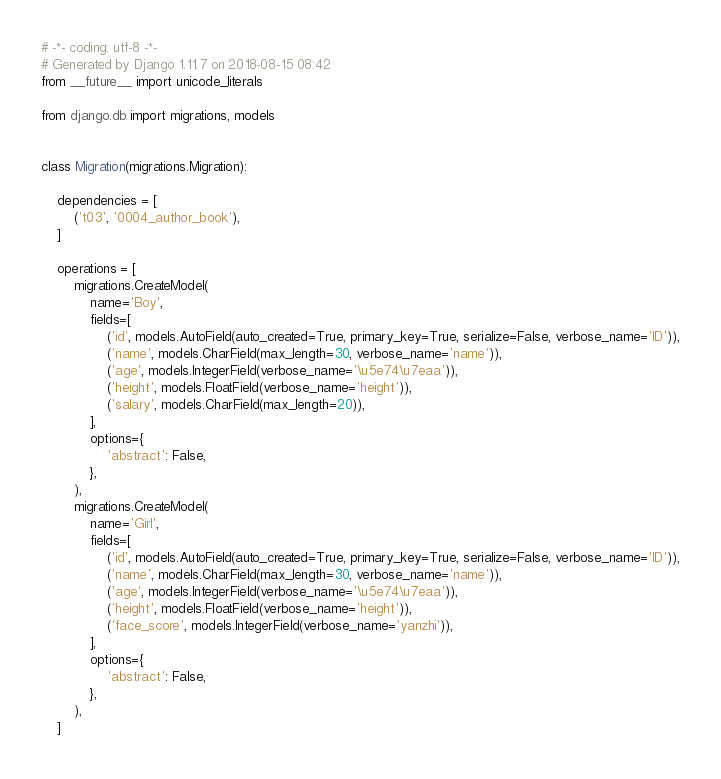<code> <loc_0><loc_0><loc_500><loc_500><_Python_># -*- coding: utf-8 -*-
# Generated by Django 1.11.7 on 2018-08-15 08:42
from __future__ import unicode_literals

from django.db import migrations, models


class Migration(migrations.Migration):

    dependencies = [
        ('t03', '0004_author_book'),
    ]

    operations = [
        migrations.CreateModel(
            name='Boy',
            fields=[
                ('id', models.AutoField(auto_created=True, primary_key=True, serialize=False, verbose_name='ID')),
                ('name', models.CharField(max_length=30, verbose_name='name')),
                ('age', models.IntegerField(verbose_name='\u5e74\u7eaa')),
                ('height', models.FloatField(verbose_name='height')),
                ('salary', models.CharField(max_length=20)),
            ],
            options={
                'abstract': False,
            },
        ),
        migrations.CreateModel(
            name='Girl',
            fields=[
                ('id', models.AutoField(auto_created=True, primary_key=True, serialize=False, verbose_name='ID')),
                ('name', models.CharField(max_length=30, verbose_name='name')),
                ('age', models.IntegerField(verbose_name='\u5e74\u7eaa')),
                ('height', models.FloatField(verbose_name='height')),
                ('face_score', models.IntegerField(verbose_name='yanzhi')),
            ],
            options={
                'abstract': False,
            },
        ),
    ]
</code> 